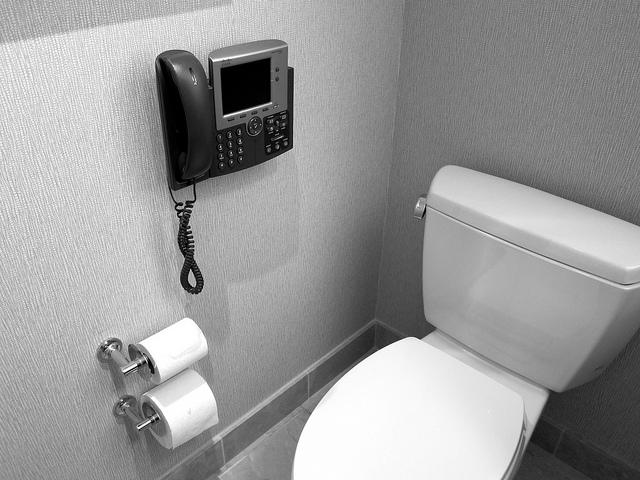Is this a corporate bathroom?
Short answer required. Yes. What is on the wall?
Short answer required. Phone. How many toilet paper rolls?
Concise answer only. 2. 